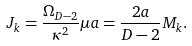Convert formula to latex. <formula><loc_0><loc_0><loc_500><loc_500>J _ { k } = \frac { \Omega _ { D - 2 } } { \kappa ^ { 2 } } \mu a = \frac { 2 a } { D - 2 } M _ { k } .</formula> 